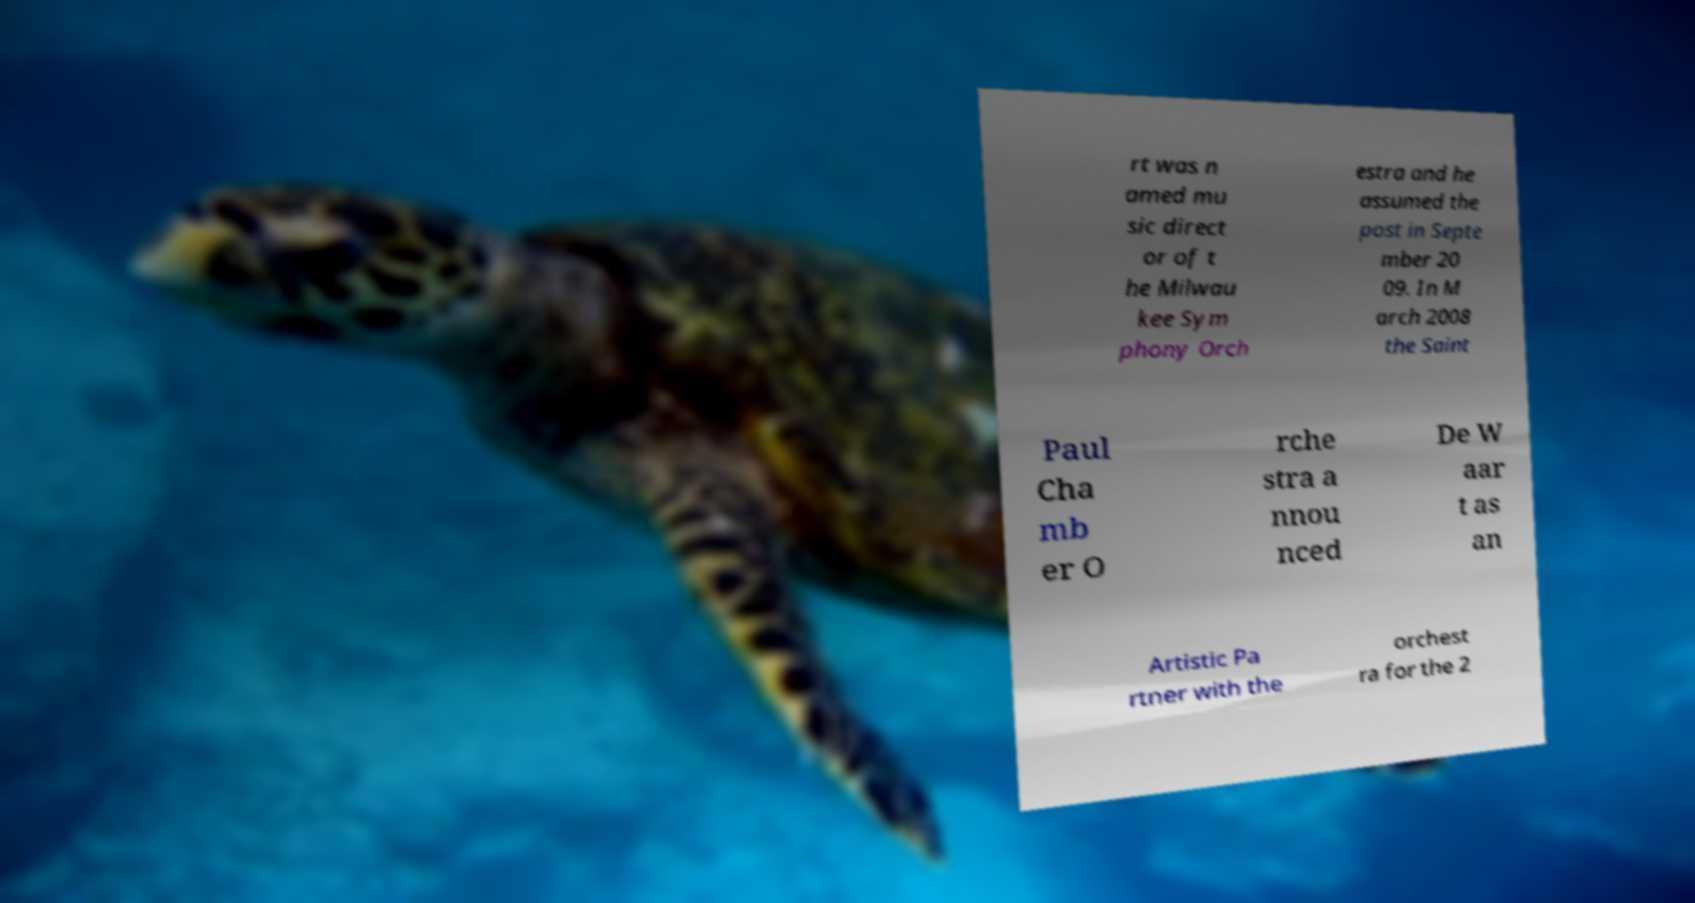There's text embedded in this image that I need extracted. Can you transcribe it verbatim? rt was n amed mu sic direct or of t he Milwau kee Sym phony Orch estra and he assumed the post in Septe mber 20 09. In M arch 2008 the Saint Paul Cha mb er O rche stra a nnou nced De W aar t as an Artistic Pa rtner with the orchest ra for the 2 